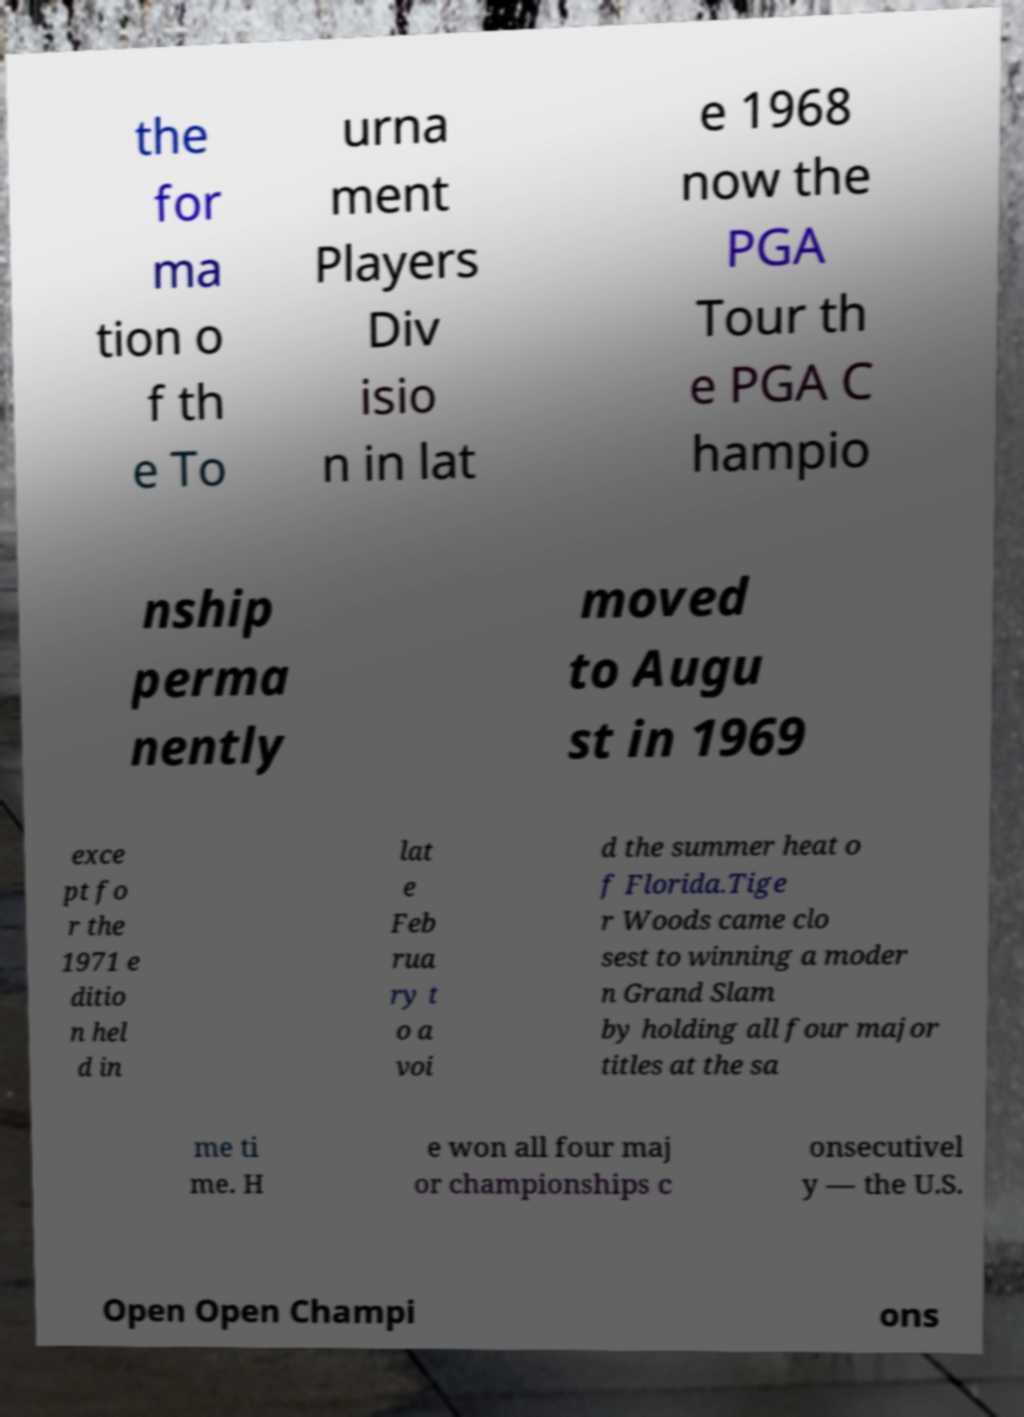For documentation purposes, I need the text within this image transcribed. Could you provide that? the for ma tion o f th e To urna ment Players Div isio n in lat e 1968 now the PGA Tour th e PGA C hampio nship perma nently moved to Augu st in 1969 exce pt fo r the 1971 e ditio n hel d in lat e Feb rua ry t o a voi d the summer heat o f Florida.Tige r Woods came clo sest to winning a moder n Grand Slam by holding all four major titles at the sa me ti me. H e won all four maj or championships c onsecutivel y — the U.S. Open Open Champi ons 